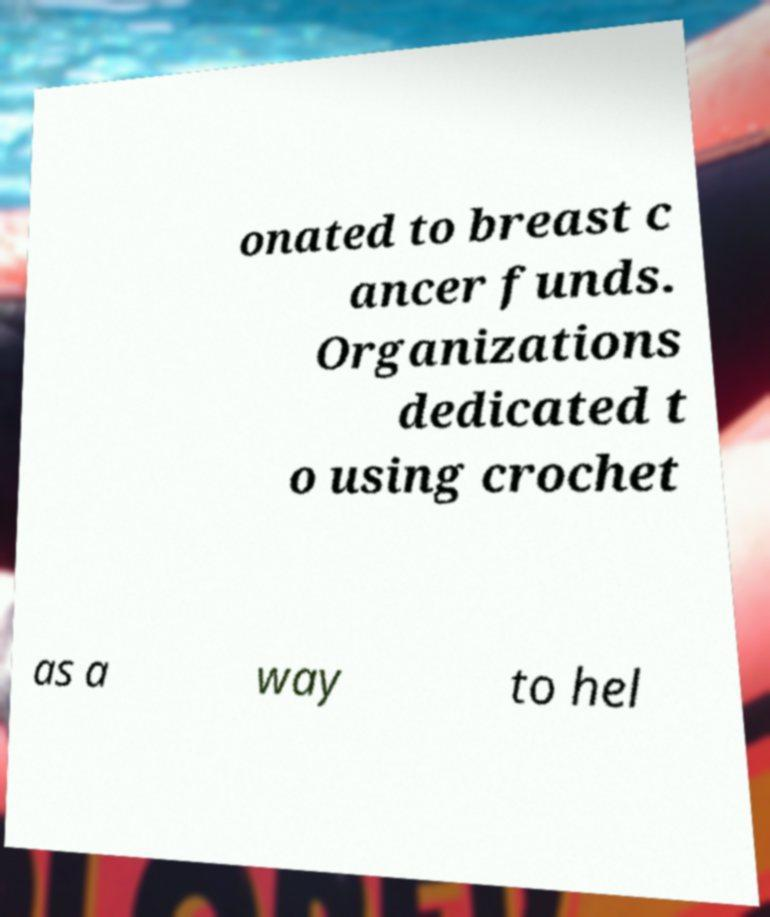There's text embedded in this image that I need extracted. Can you transcribe it verbatim? onated to breast c ancer funds. Organizations dedicated t o using crochet as a way to hel 